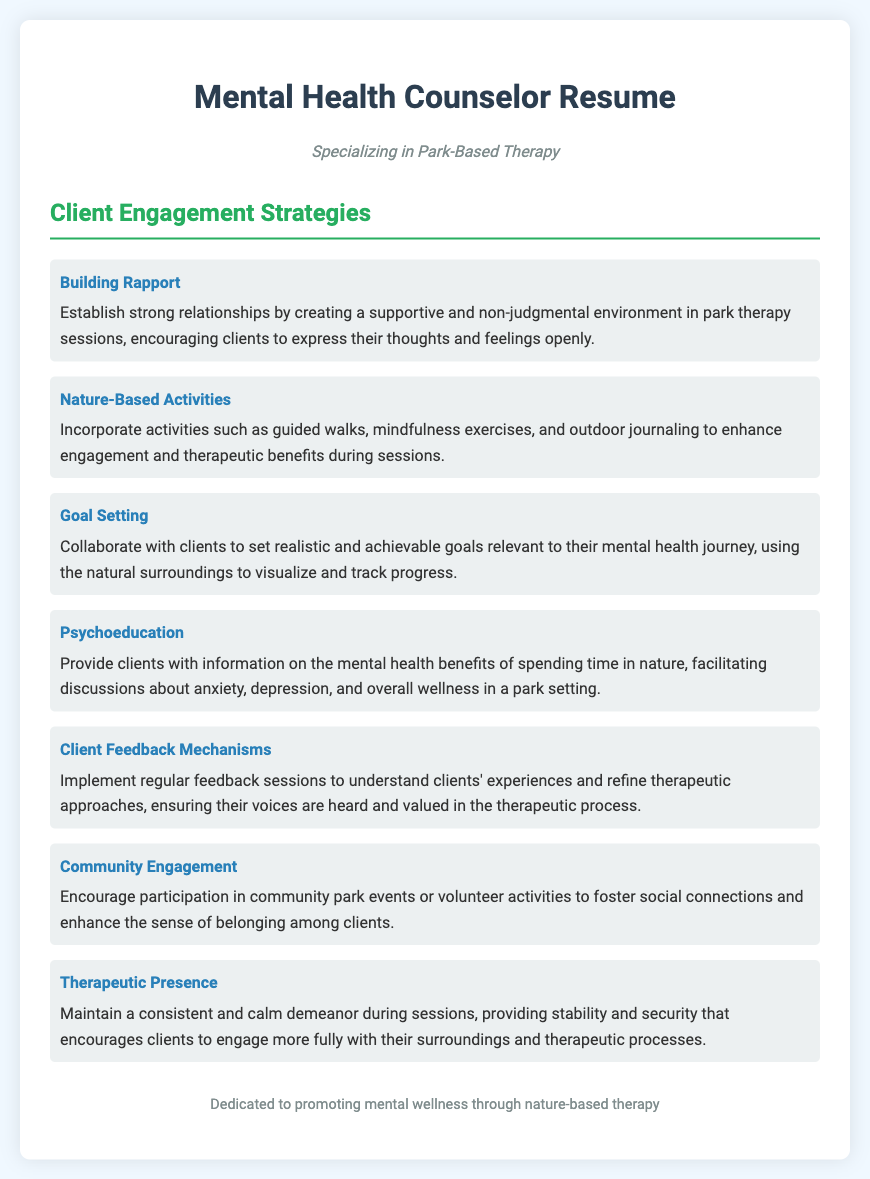what is the main focus of the resume? The subtitle indicates the specialization of the counselor in their practice.
Answer: Park-Based Therapy how many client engagement strategies are listed? The number of strategies can be counted from the document's bulleted list.
Answer: Seven what is one activity mentioned under Nature-Based Activities? The activities listed in the strategy can be recalled from the document.
Answer: Guided walks who is the resume targeted towards? The introduction and the content of the document suggest the intended audience.
Answer: Employers what client feedback method is mentioned? This can be directly retrieved from the client engagement strategies section.
Answer: Feedback sessions which therapeutic strategy encourages social connections? The document provides strategies aimed at building social connections.
Answer: Community Engagement what is an important quality for therapeutic presence? The description under this strategy highlights a key attribute.
Answer: Consistent demeanor which aspect of mental health does Psychoeducation address? The document explicitly mentions the relevant mental health issues associated with this strategy.
Answer: Anxiety and depression 